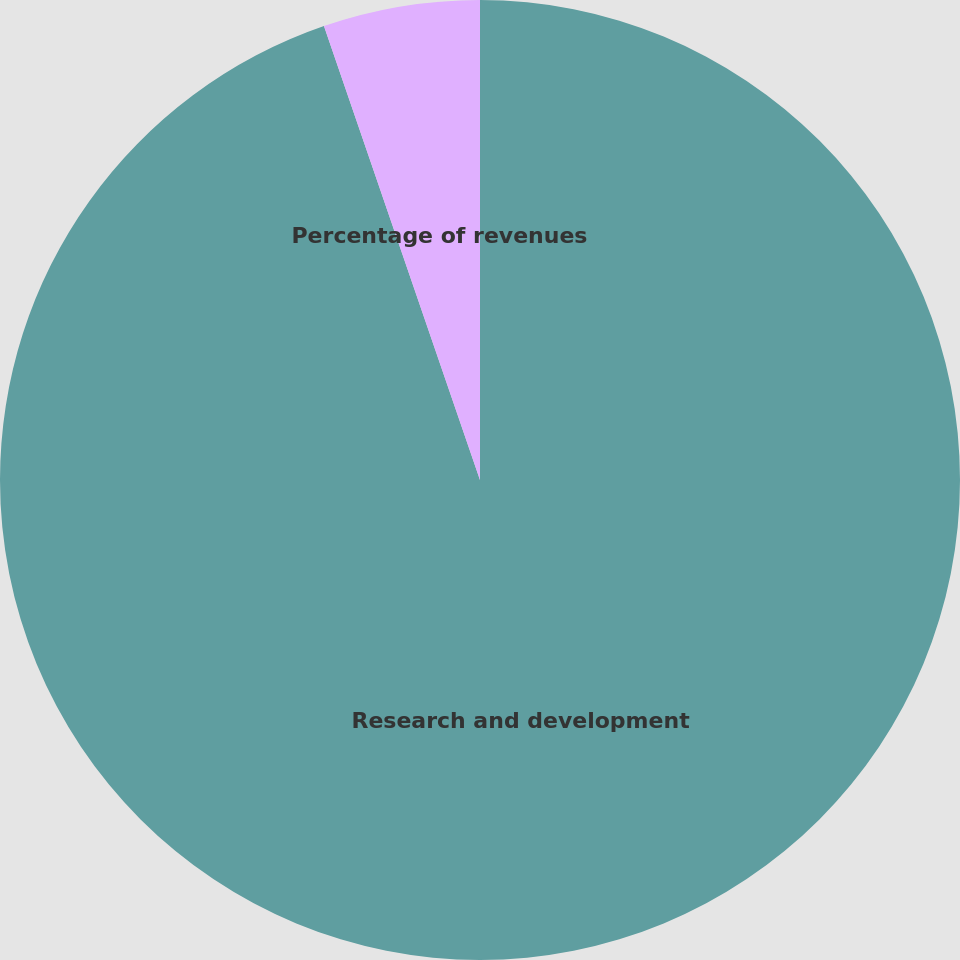Convert chart to OTSL. <chart><loc_0><loc_0><loc_500><loc_500><pie_chart><fcel>Research and development<fcel>Percentage of revenues<nl><fcel>94.73%<fcel>5.27%<nl></chart> 